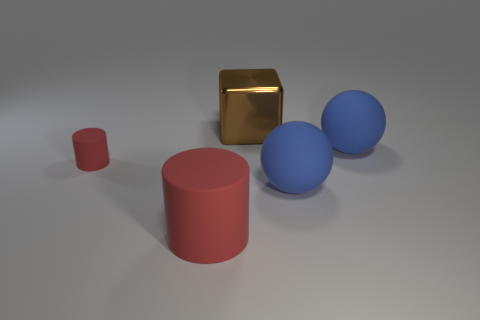Is the surface the objects are on reflective, and can you tell what material the objects might be made of? The surface appears to be somewhat reflective, given the subtle reflections seen under the objects. The brown cube seems to have a metallic finish, likely representing a material such as copper or bronze. The blue spheres have a matte finish and could be made of a material like plastic or painted wood, whereas the red cylinder's appearance is suggestive of a smooth, matte surface, akin to painted ceramic or hard plastic. 